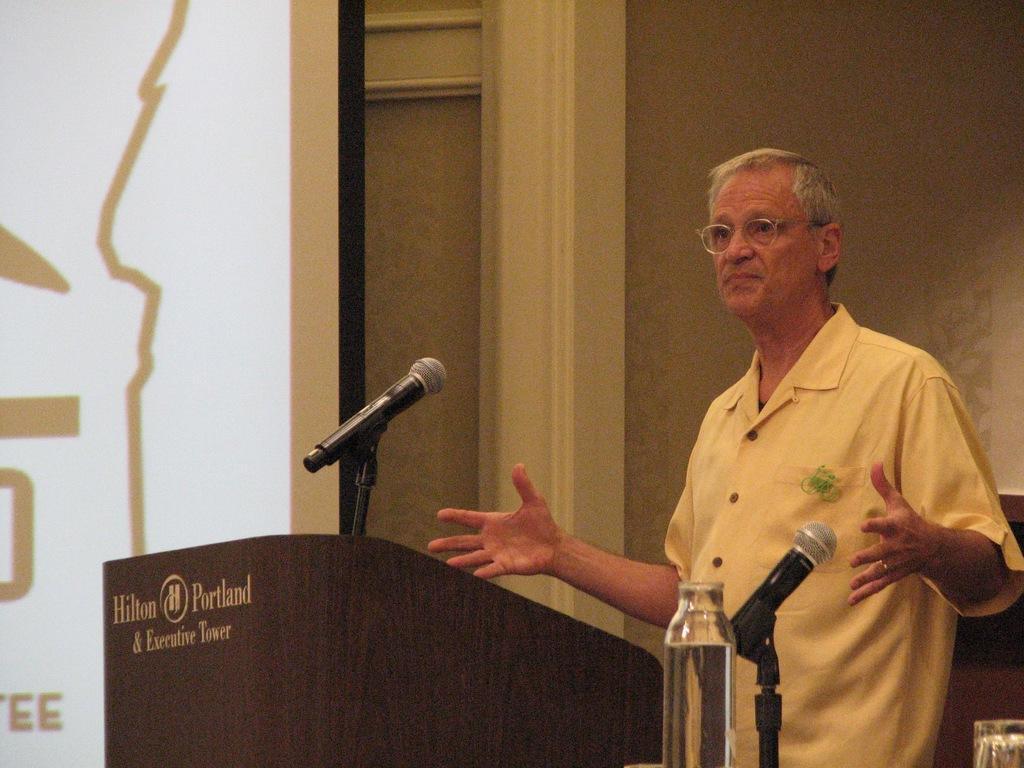Could you give a brief overview of what you see in this image? In this image an old man is standing in front of a podium. there are two mics in front of him. there is a bottle. In the background there is a screen and wall. The old man is wearing white shirt and glasses. 